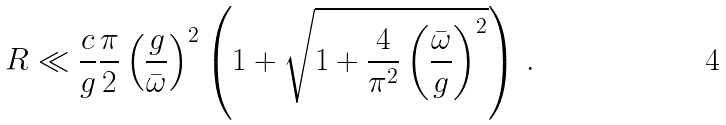Convert formula to latex. <formula><loc_0><loc_0><loc_500><loc_500>R \ll \frac { c } { g } \frac { \pi } { 2 } \left ( \frac { g } { \bar { \omega } } \right ) ^ { 2 } \left ( 1 + \sqrt { 1 + \frac { 4 } { \pi ^ { 2 } } \left ( \frac { \bar { \omega } } { g } \right ) ^ { 2 } } \right ) \, .</formula> 